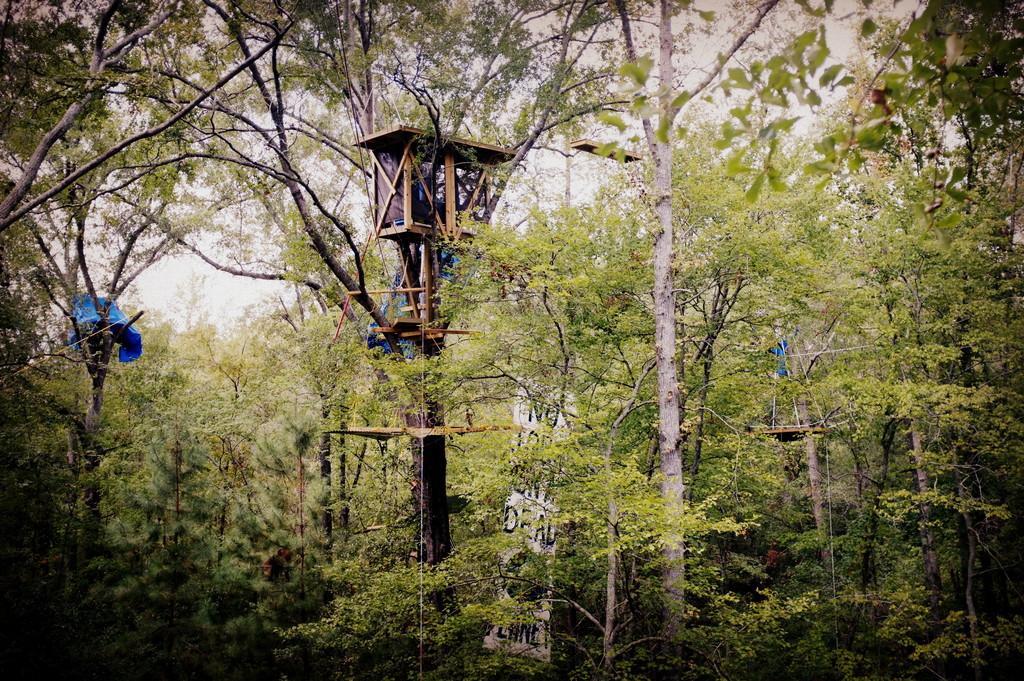Could you give a brief overview of what you see in this image? In the picture we can see a forest with full of plants and trees and we can see a pole with small shed on top of it and from the trees we can see a part of sky. 